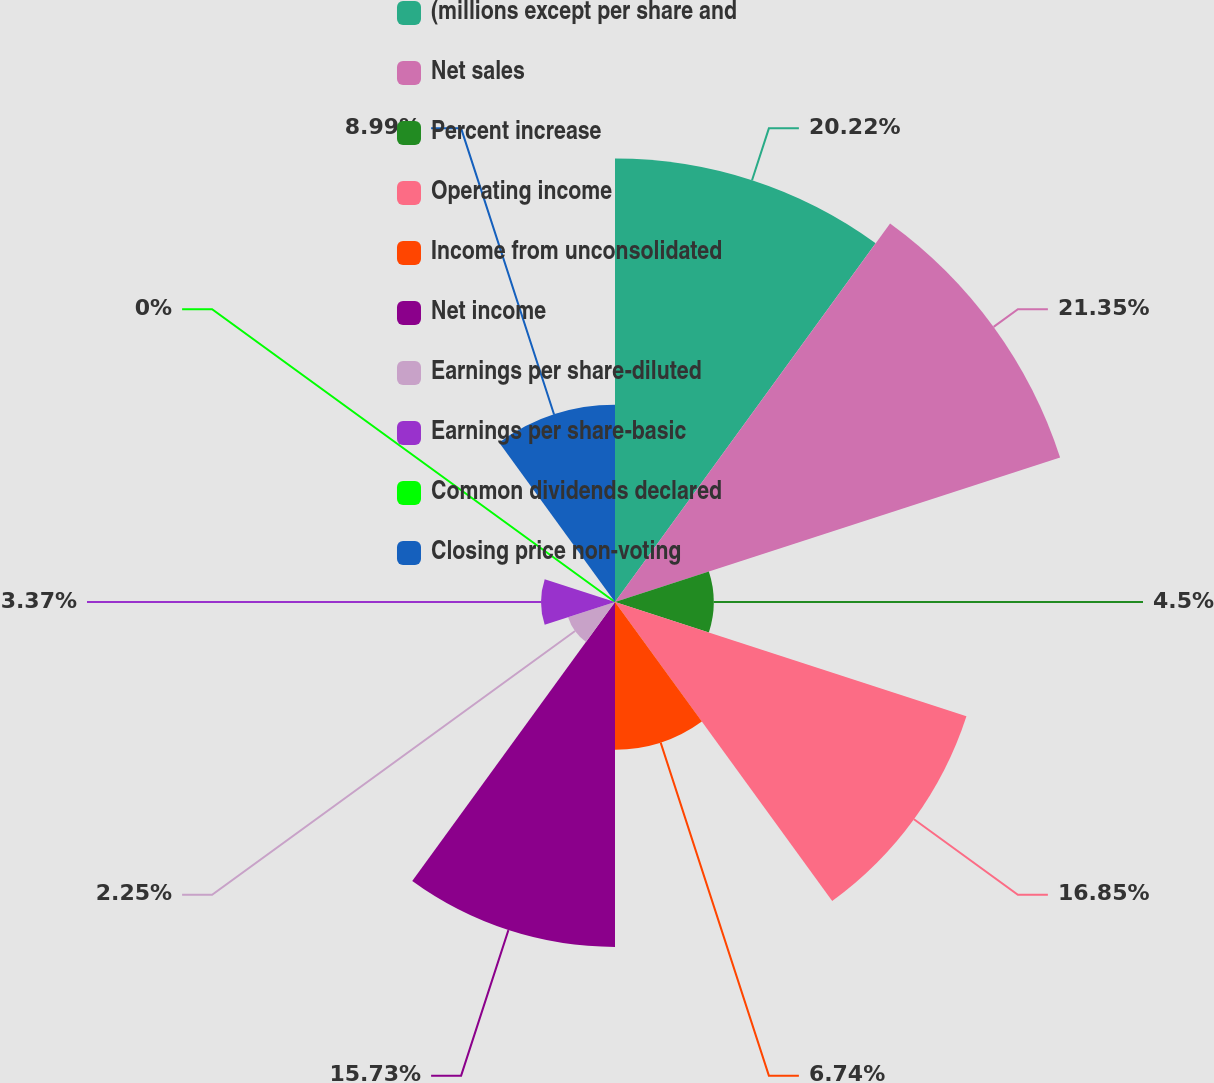Convert chart. <chart><loc_0><loc_0><loc_500><loc_500><pie_chart><fcel>(millions except per share and<fcel>Net sales<fcel>Percent increase<fcel>Operating income<fcel>Income from unconsolidated<fcel>Net income<fcel>Earnings per share-diluted<fcel>Earnings per share-basic<fcel>Common dividends declared<fcel>Closing price non-voting<nl><fcel>20.22%<fcel>21.34%<fcel>4.5%<fcel>16.85%<fcel>6.74%<fcel>15.73%<fcel>2.25%<fcel>3.37%<fcel>0.0%<fcel>8.99%<nl></chart> 